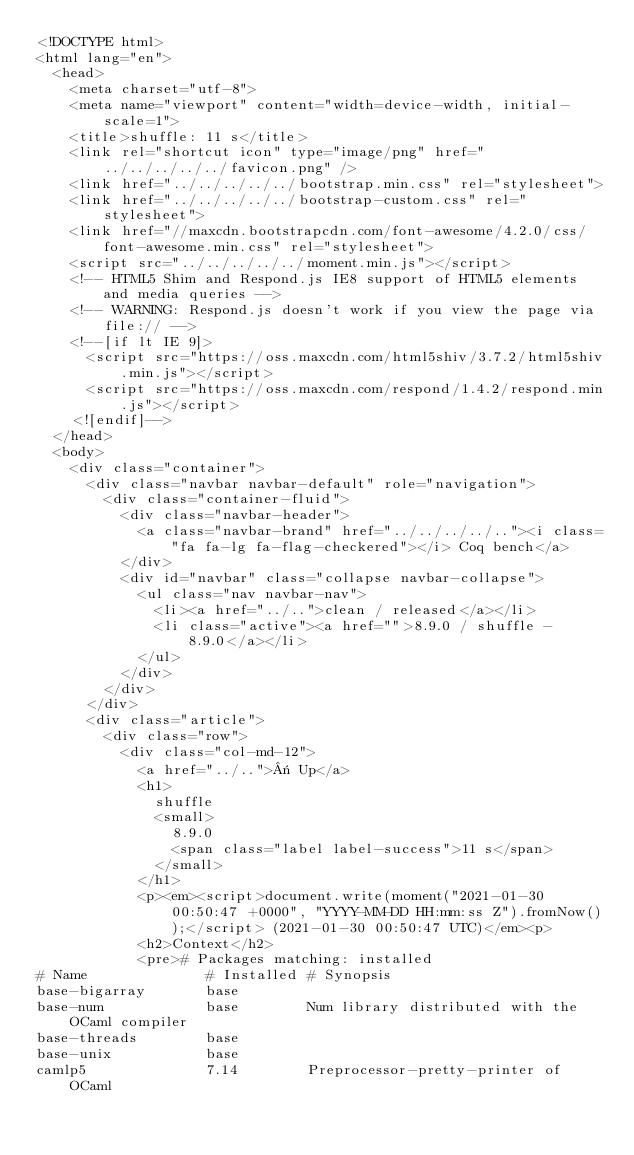<code> <loc_0><loc_0><loc_500><loc_500><_HTML_><!DOCTYPE html>
<html lang="en">
  <head>
    <meta charset="utf-8">
    <meta name="viewport" content="width=device-width, initial-scale=1">
    <title>shuffle: 11 s</title>
    <link rel="shortcut icon" type="image/png" href="../../../../../favicon.png" />
    <link href="../../../../../bootstrap.min.css" rel="stylesheet">
    <link href="../../../../../bootstrap-custom.css" rel="stylesheet">
    <link href="//maxcdn.bootstrapcdn.com/font-awesome/4.2.0/css/font-awesome.min.css" rel="stylesheet">
    <script src="../../../../../moment.min.js"></script>
    <!-- HTML5 Shim and Respond.js IE8 support of HTML5 elements and media queries -->
    <!-- WARNING: Respond.js doesn't work if you view the page via file:// -->
    <!--[if lt IE 9]>
      <script src="https://oss.maxcdn.com/html5shiv/3.7.2/html5shiv.min.js"></script>
      <script src="https://oss.maxcdn.com/respond/1.4.2/respond.min.js"></script>
    <![endif]-->
  </head>
  <body>
    <div class="container">
      <div class="navbar navbar-default" role="navigation">
        <div class="container-fluid">
          <div class="navbar-header">
            <a class="navbar-brand" href="../../../../.."><i class="fa fa-lg fa-flag-checkered"></i> Coq bench</a>
          </div>
          <div id="navbar" class="collapse navbar-collapse">
            <ul class="nav navbar-nav">
              <li><a href="../..">clean / released</a></li>
              <li class="active"><a href="">8.9.0 / shuffle - 8.9.0</a></li>
            </ul>
          </div>
        </div>
      </div>
      <div class="article">
        <div class="row">
          <div class="col-md-12">
            <a href="../..">« Up</a>
            <h1>
              shuffle
              <small>
                8.9.0
                <span class="label label-success">11 s</span>
              </small>
            </h1>
            <p><em><script>document.write(moment("2021-01-30 00:50:47 +0000", "YYYY-MM-DD HH:mm:ss Z").fromNow());</script> (2021-01-30 00:50:47 UTC)</em><p>
            <h2>Context</h2>
            <pre># Packages matching: installed
# Name              # Installed # Synopsis
base-bigarray       base
base-num            base        Num library distributed with the OCaml compiler
base-threads        base
base-unix           base
camlp5              7.14        Preprocessor-pretty-printer of OCaml</code> 